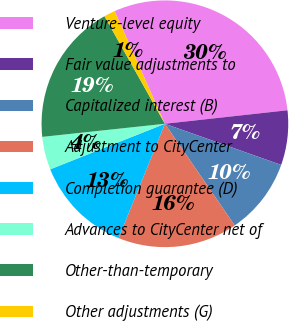Convert chart to OTSL. <chart><loc_0><loc_0><loc_500><loc_500><pie_chart><fcel>Venture-level equity<fcel>Fair value adjustments to<fcel>Capitalized interest (B)<fcel>Adjustment to CityCenter<fcel>Completion guarantee (D)<fcel>Advances to CityCenter net of<fcel>Other-than-temporary<fcel>Other adjustments (G)<nl><fcel>29.93%<fcel>7.16%<fcel>10.01%<fcel>15.7%<fcel>12.86%<fcel>4.32%<fcel>18.55%<fcel>1.47%<nl></chart> 